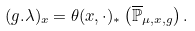Convert formula to latex. <formula><loc_0><loc_0><loc_500><loc_500>( g . \lambda ) _ { x } = \theta ( x , \cdot ) _ { \ast } \left ( \overline { \mathbb { P } } _ { \mu , x , g } \right ) .</formula> 